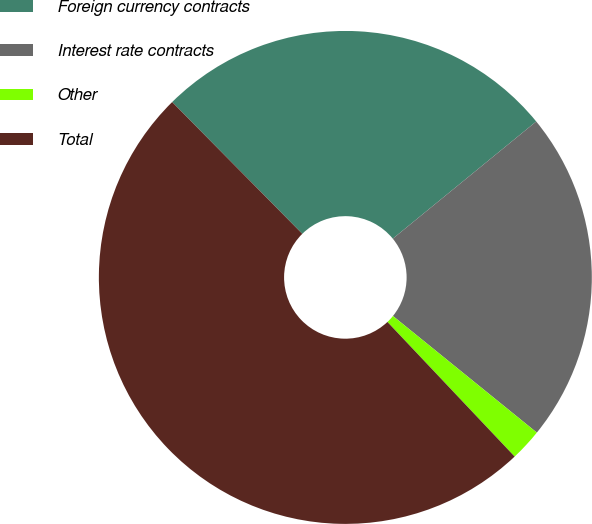Convert chart to OTSL. <chart><loc_0><loc_0><loc_500><loc_500><pie_chart><fcel>Foreign currency contracts<fcel>Interest rate contracts<fcel>Other<fcel>Total<nl><fcel>26.5%<fcel>21.74%<fcel>2.11%<fcel>49.65%<nl></chart> 